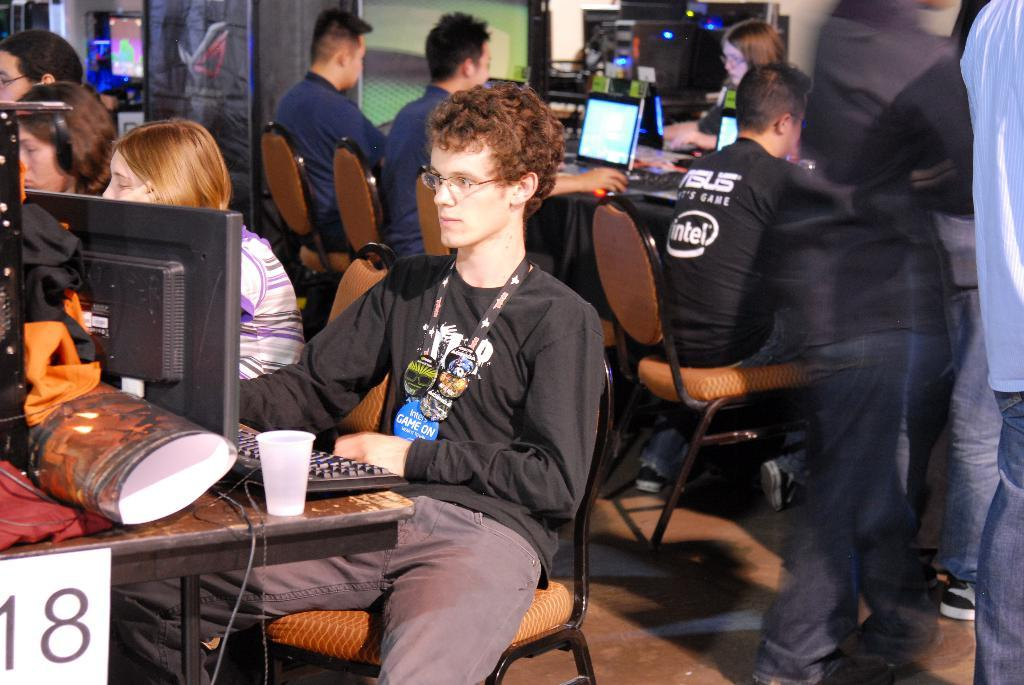How many persons are visible in the image? There are multiple persons in the image. What are the persons doing in the image? The persons are sitting on chairs. What objects are present on the tables in front of the persons? There are computers, glasses, and laptops on the tables. What type of linen can be seen draped over the laptops in the image? There is no linen draped over the laptops in the image. How many clovers are visible on the tables in the image? There are no clovers present in the image. 